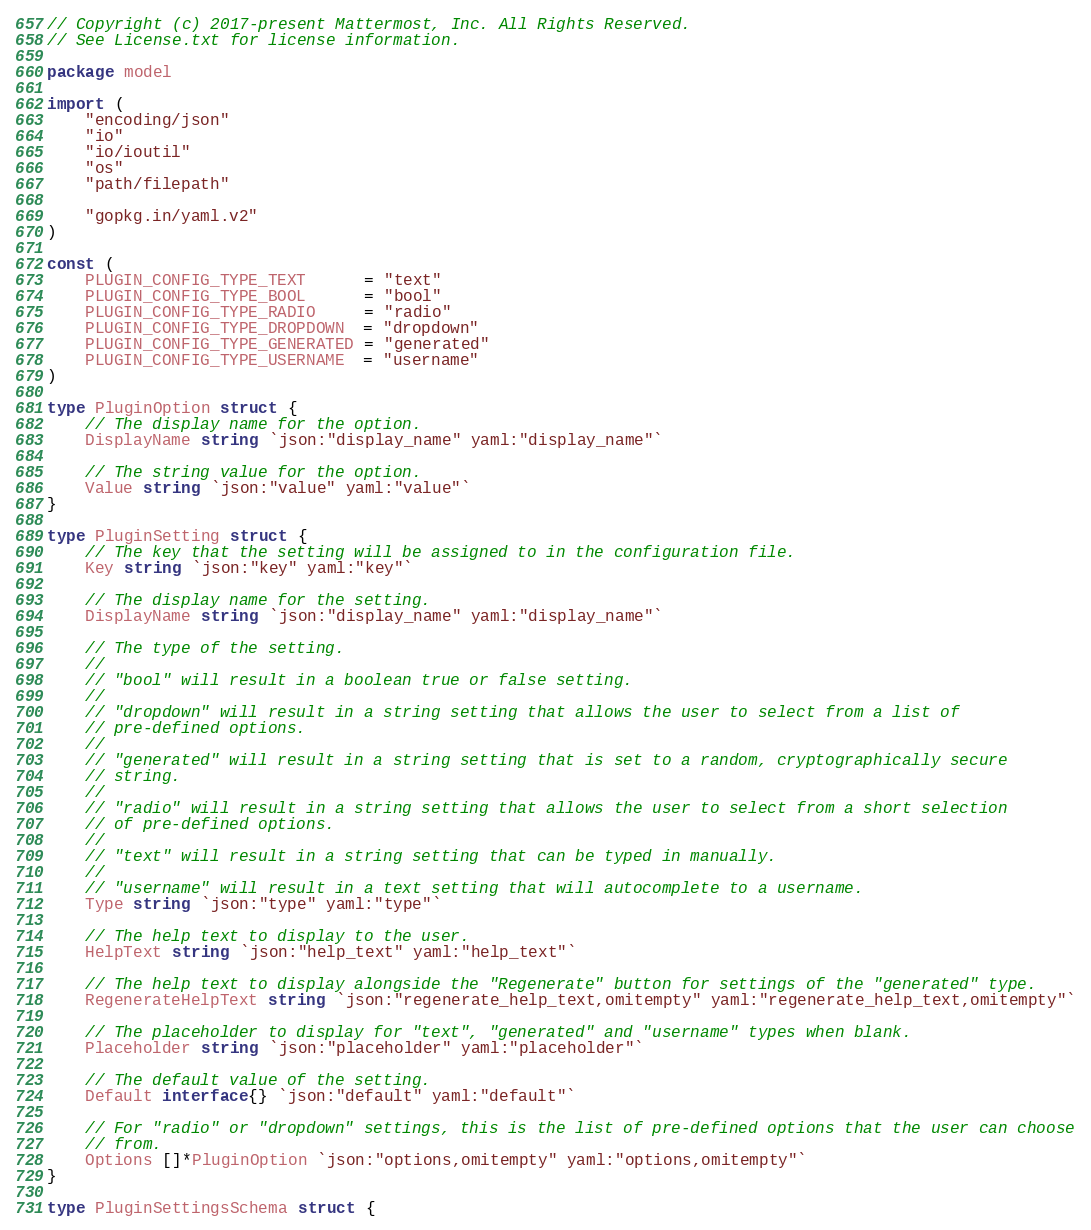Convert code to text. <code><loc_0><loc_0><loc_500><loc_500><_Go_>// Copyright (c) 2017-present Mattermost, Inc. All Rights Reserved.
// See License.txt for license information.

package model

import (
	"encoding/json"
	"io"
	"io/ioutil"
	"os"
	"path/filepath"

	"gopkg.in/yaml.v2"
)

const (
	PLUGIN_CONFIG_TYPE_TEXT      = "text"
	PLUGIN_CONFIG_TYPE_BOOL      = "bool"
	PLUGIN_CONFIG_TYPE_RADIO     = "radio"
	PLUGIN_CONFIG_TYPE_DROPDOWN  = "dropdown"
	PLUGIN_CONFIG_TYPE_GENERATED = "generated"
	PLUGIN_CONFIG_TYPE_USERNAME  = "username"
)

type PluginOption struct {
	// The display name for the option.
	DisplayName string `json:"display_name" yaml:"display_name"`

	// The string value for the option.
	Value string `json:"value" yaml:"value"`
}

type PluginSetting struct {
	// The key that the setting will be assigned to in the configuration file.
	Key string `json:"key" yaml:"key"`

	// The display name for the setting.
	DisplayName string `json:"display_name" yaml:"display_name"`

	// The type of the setting.
	//
	// "bool" will result in a boolean true or false setting.
	//
	// "dropdown" will result in a string setting that allows the user to select from a list of
	// pre-defined options.
	//
	// "generated" will result in a string setting that is set to a random, cryptographically secure
	// string.
	//
	// "radio" will result in a string setting that allows the user to select from a short selection
	// of pre-defined options.
	//
	// "text" will result in a string setting that can be typed in manually.
	//
	// "username" will result in a text setting that will autocomplete to a username.
	Type string `json:"type" yaml:"type"`

	// The help text to display to the user.
	HelpText string `json:"help_text" yaml:"help_text"`

	// The help text to display alongside the "Regenerate" button for settings of the "generated" type.
	RegenerateHelpText string `json:"regenerate_help_text,omitempty" yaml:"regenerate_help_text,omitempty"`

	// The placeholder to display for "text", "generated" and "username" types when blank.
	Placeholder string `json:"placeholder" yaml:"placeholder"`

	// The default value of the setting.
	Default interface{} `json:"default" yaml:"default"`

	// For "radio" or "dropdown" settings, this is the list of pre-defined options that the user can choose
	// from.
	Options []*PluginOption `json:"options,omitempty" yaml:"options,omitempty"`
}

type PluginSettingsSchema struct {</code> 